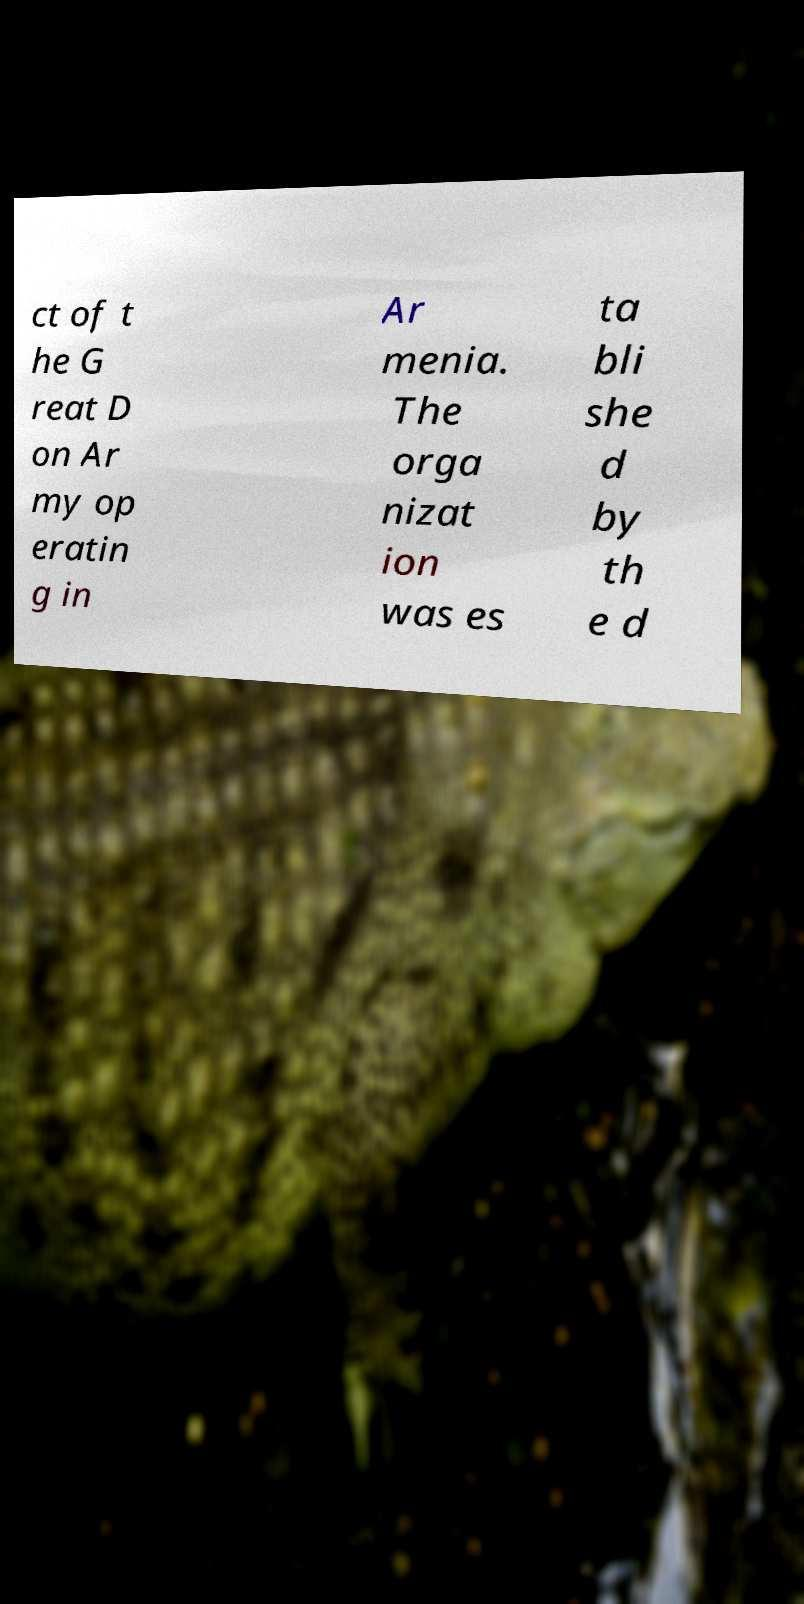I need the written content from this picture converted into text. Can you do that? ct of t he G reat D on Ar my op eratin g in Ar menia. The orga nizat ion was es ta bli she d by th e d 